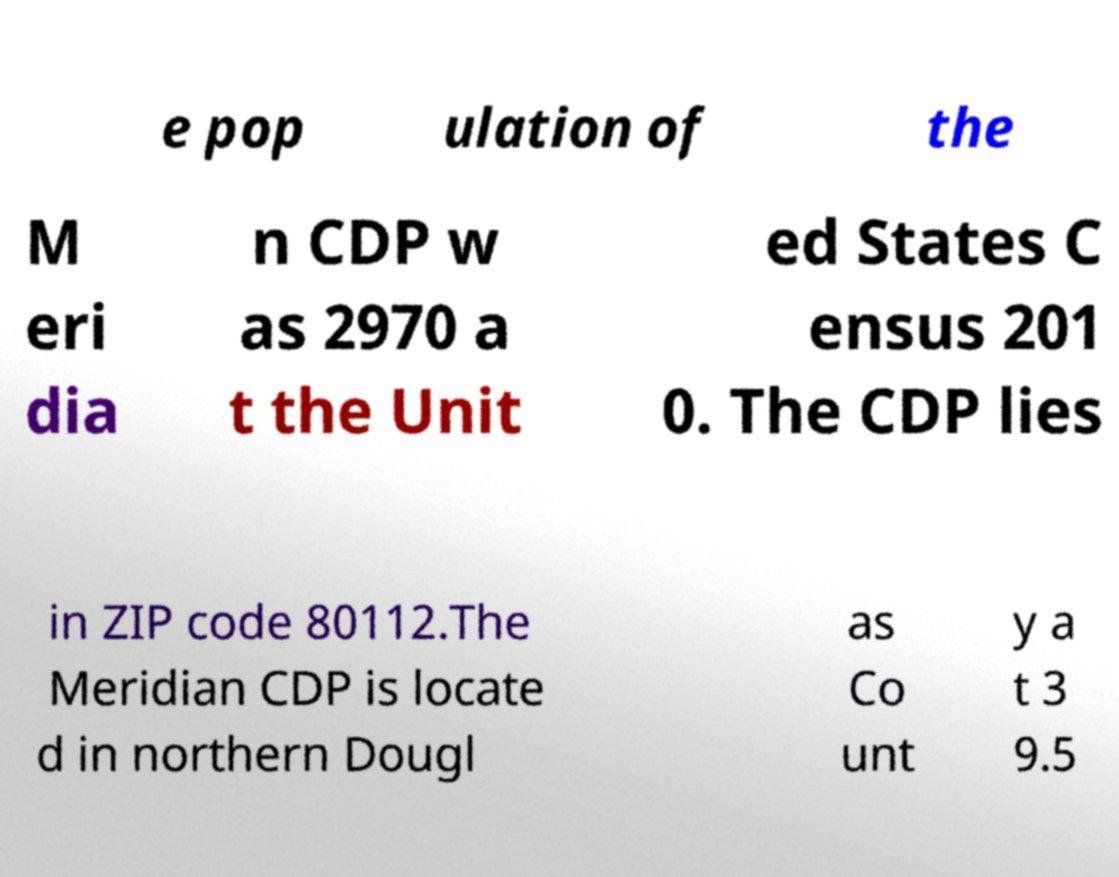There's text embedded in this image that I need extracted. Can you transcribe it verbatim? e pop ulation of the M eri dia n CDP w as 2970 a t the Unit ed States C ensus 201 0. The CDP lies in ZIP code 80112.The Meridian CDP is locate d in northern Dougl as Co unt y a t 3 9.5 